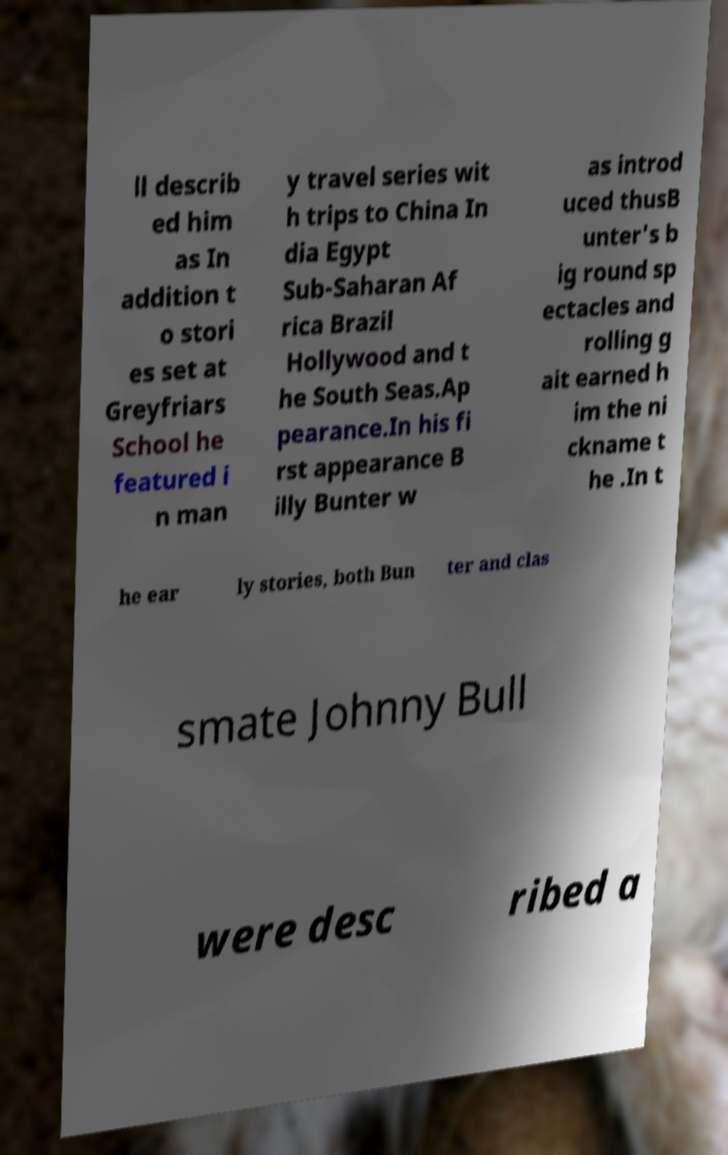There's text embedded in this image that I need extracted. Can you transcribe it verbatim? ll describ ed him as In addition t o stori es set at Greyfriars School he featured i n man y travel series wit h trips to China In dia Egypt Sub-Saharan Af rica Brazil Hollywood and t he South Seas.Ap pearance.In his fi rst appearance B illy Bunter w as introd uced thusB unter's b ig round sp ectacles and rolling g ait earned h im the ni ckname t he .In t he ear ly stories, both Bun ter and clas smate Johnny Bull were desc ribed a 